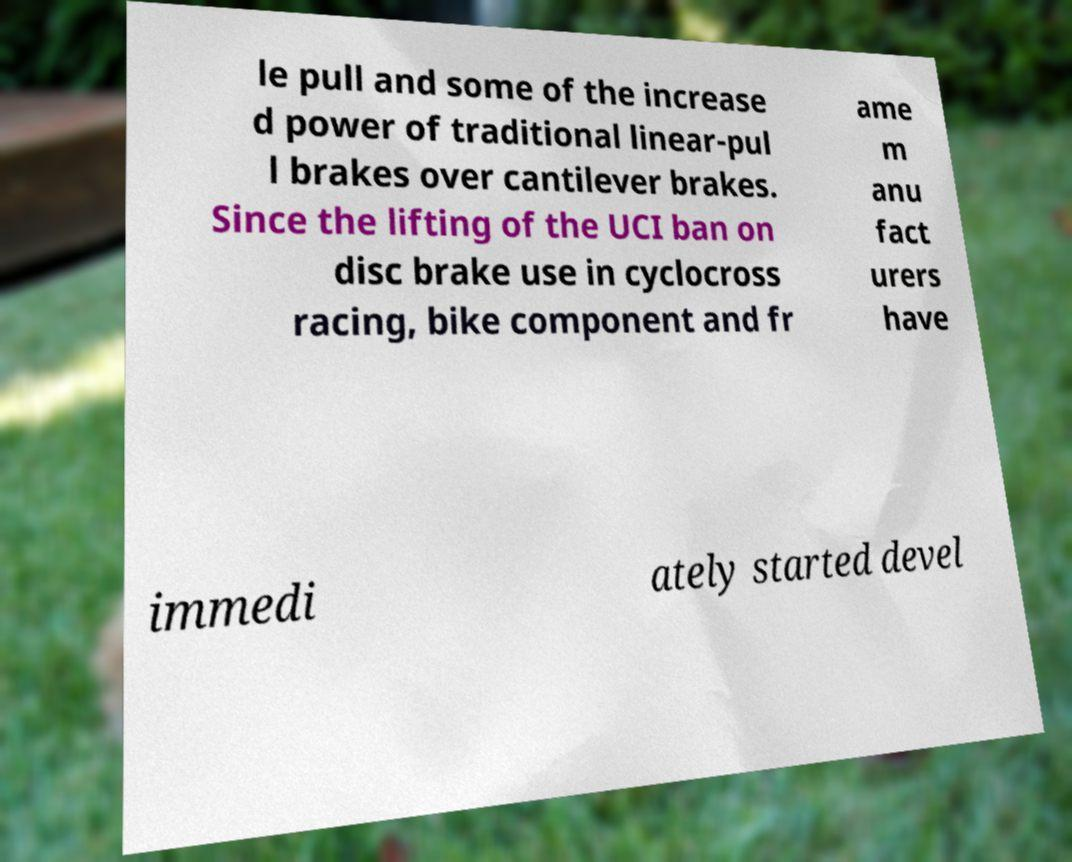Could you extract and type out the text from this image? le pull and some of the increase d power of traditional linear-pul l brakes over cantilever brakes. Since the lifting of the UCI ban on disc brake use in cyclocross racing, bike component and fr ame m anu fact urers have immedi ately started devel 